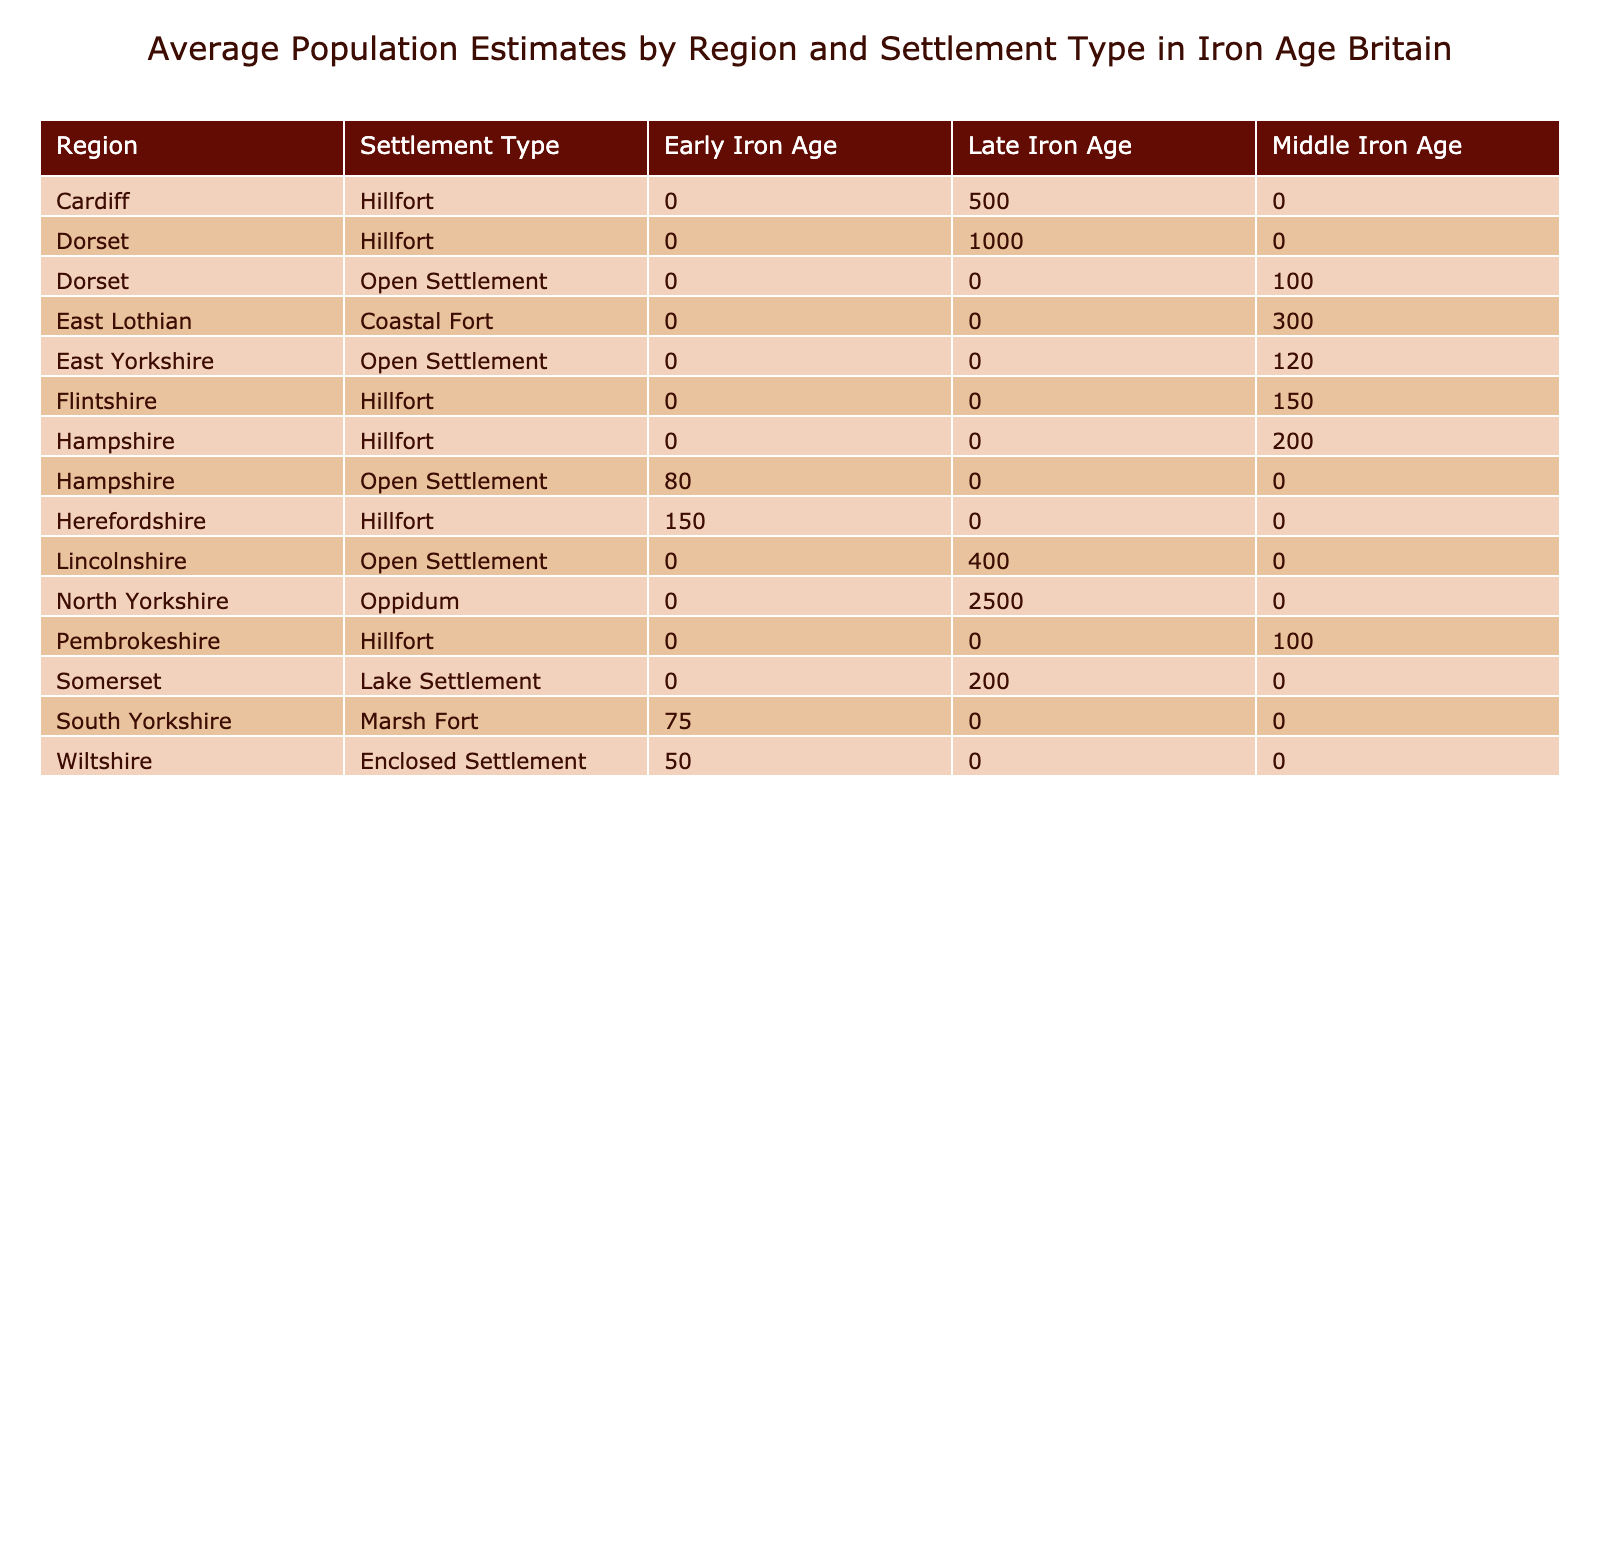What is the average population estimate for Hillforts in the Late Iron Age? To find the average population estimate for Hillforts in the Late Iron Age, we look at the population estimates listed for each Hillfort under that period. The relevant values are 1000 (Maiden Castle), 500 (Caerau), and 150 (Moel y Gaer). We sum these values: 1000 + 500 + 150 = 1650, and then divide by the number of Hillforts, which is 3. So, 1650 / 3 = 550.
Answer: 550 Which Settlement Type in Hampshire has the highest population estimate? In Hampshire, we see that there are Hillfort (Danebury), which has a population estimate of 200, and Open Settlement (Winnall Down) with a population estimate of 80. Since 200 is greater than 80, Hillfort (Danebury) has the highest estimate.
Answer: Hillfort (Danebury) Is there any site in the early Iron Age with defensive features? We can check each Early Iron Age site for the presence of defensive features. For Sutton Common, it has a Wooden Palisade, while Croft Ambrey has Stone Walls. Hence, both sites have defensive features.
Answer: Yes How many more people, on average, do Coastal Forts have compared to Open Settlements in the Late Iron Age? The average population estimate for Coastal Forts in the Late Iron Age is calculated based on the single site listed, which is Broxmouth with 300. For Open Settlements, there are no sites listed under Late Iron Age, thus having an average of 0. The difference is 300 - 0 = 300.
Answer: 300 What percentage of sites in Dorset are classified as Hillforts? There are two sites in Dorset: Maiden Castle (Hillfort) and Gussage All Saints (Open Settlement), making a total of 2 sites. Only one of these is classified as a Hillfort, which gives a percentage of (1 / 2) * 100 = 50%.
Answer: 50% 